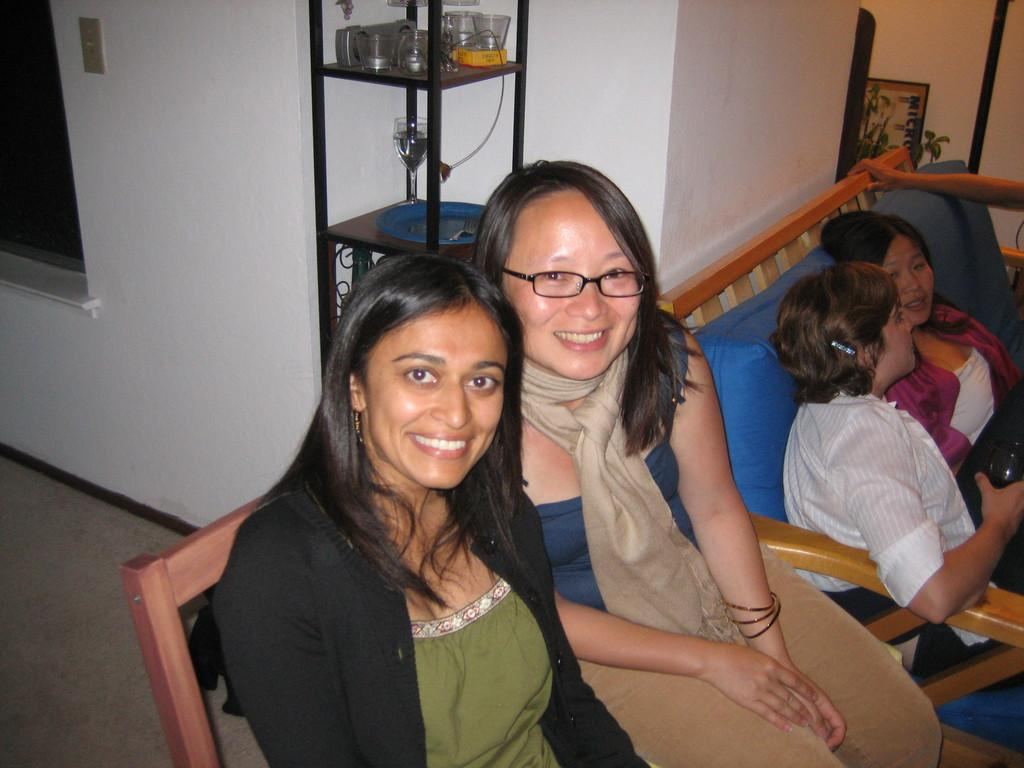Where was the image taken? The image was taken inside a room. How many people are sitting on the sofa in the image? There are four persons sitting on a sofa in the image. What objects can be seen in the image that are typically used for drinking? There are glasses visible in the image. What is located on the right side of the image? There is a photo frame on the right side of the image. What type of flag is being waved by the person in the image? There is no flag or person waving a flag present in the image. How does the tub in the image prevent the persons from standing up? There is no tub present in the image, so it cannot prevent the persons from standing up. 